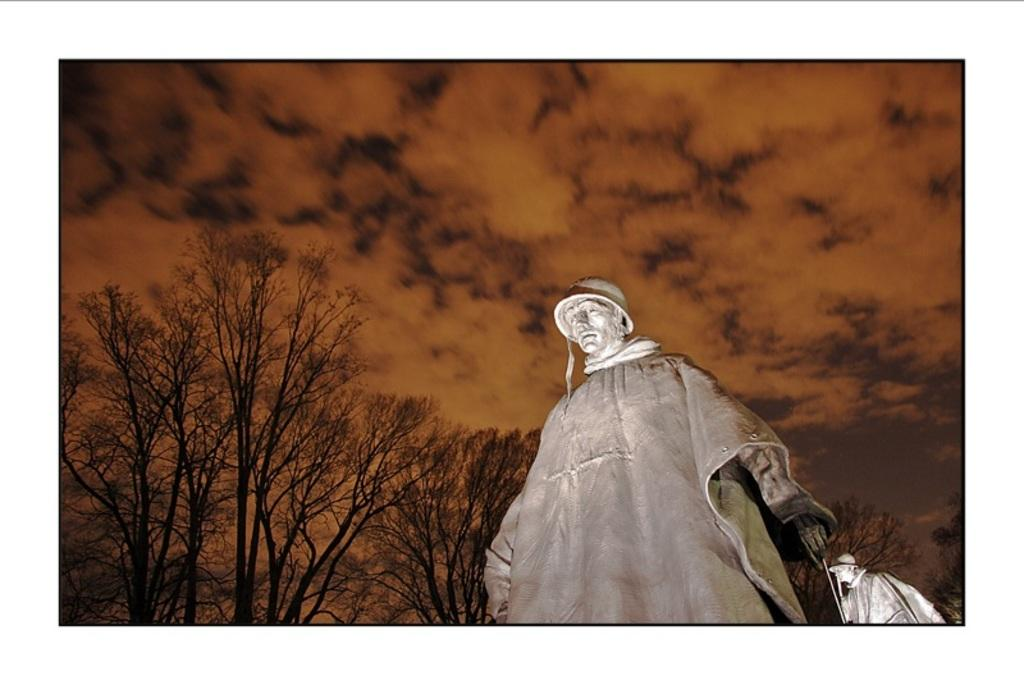How many statues can be seen in the image? There are two statues in the image. What else is present in the image besides the statues? There are big trees in the image. What can be seen in the background of the image? The sky is visible in the background of the image. How would you describe the sky in the image? The sky appears to be cloudy. What type of scale is being used by the achiever in the image? There is no achiever or scale present in the image. 